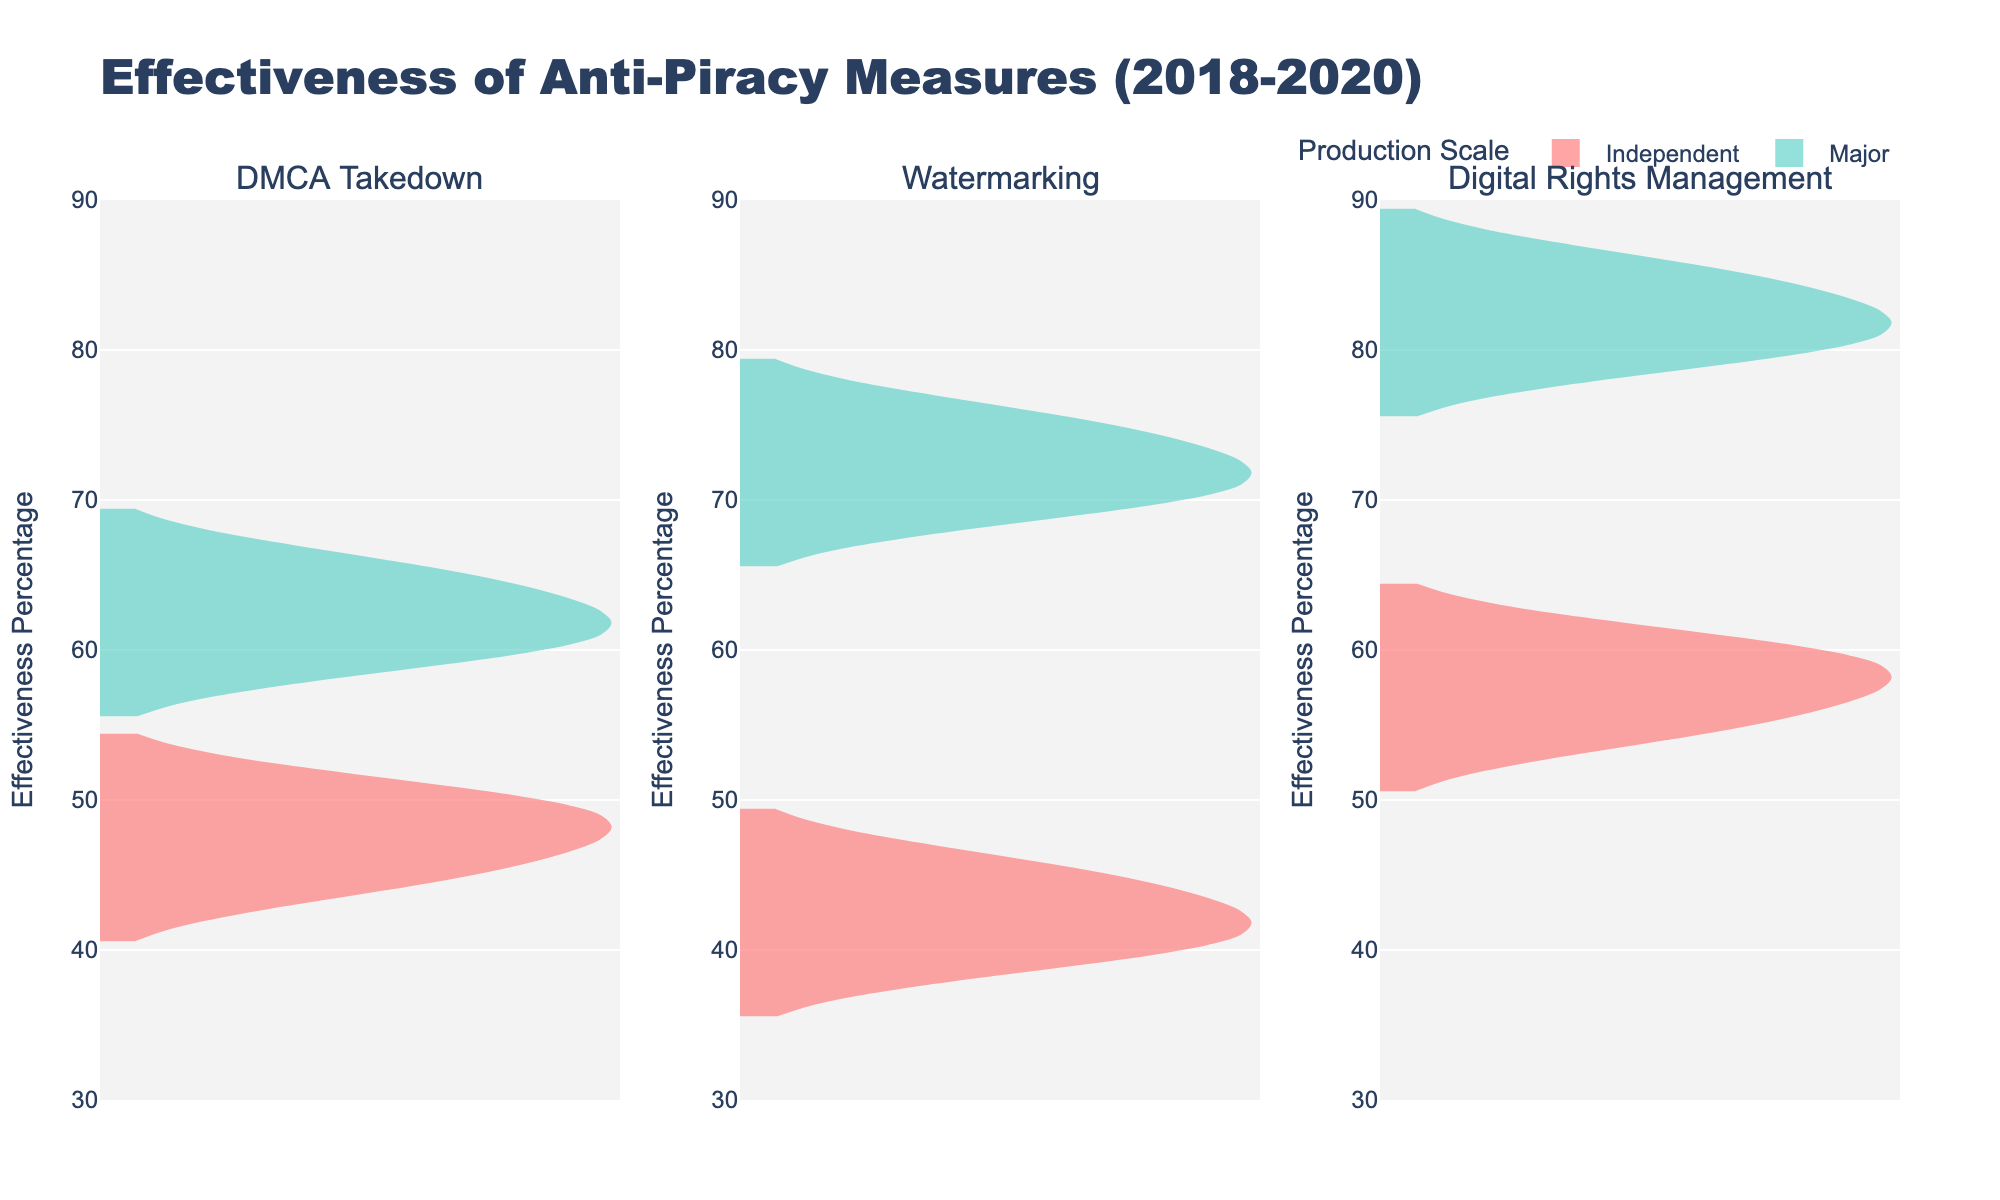Which anti-piracy measure shows the highest effectiveness for major productions in 2020? By observing the violin plots, the Digital Rights Management measure for major productions shows the highest point and median effectiveness percentage in 2020.
Answer: Digital Rights Management Which type of production (Independent or Major) shows more variation in the effectiveness of the DMCA Takedowns? By comparing the widths and spread of the violin plots for DMCA Takedowns, the Independent subplot shows more variation, indicated by a wider spread.
Answer: Independent What is the range of effectiveness percentages for watermarking in major productions? The range can be determined by observing the highest and lowest points of the watermarking violin plot for major productions. It ranges from approximately 70% to 75%.
Answer: 70% to 75% Which anti-piracy measure shows a consistent increase in effectiveness over the years for independent productions? By examining the trends in the center lines of the violin plots for independent productions across the years, both DMCA Takedown and Digital Rights Management show some increase, but Digital Rights Management shows a more notable consistency in increase.
Answer: Digital Rights Management Between DMCA Takedown and Digital Rights Management, which measure is more effective in 2018 for major productions? By comparing the median lines in the violin plots for DMCA Takedown and Digital Rights Management for major productions in 2018, Digital Rights Management shows a higher effectiveness.
Answer: Digital Rights Management What is the median effectiveness percentage of watermarking for independent productions? The median is visible as a line inside the violin plot for watermarking and independent productions, which appears around 42-45%.
Answer: 43.5% Which type of production generally benefits more from watermarking? By comparing the violin plots for watermarking independent vs. major productions, major productions show higher effectiveness percentages.
Answer: Major How does the effectiveness of DMCA Takedowns for independent productions change from 2018 to 2020? By examining the median lines for DMCA Takedowns under independent productions, we can see a slight increase from 45% in 2018 to 50% in 2020.
Answer: It increases What trend can be observed for the effectiveness of Digital Rights Management for both independent and major productions? Both independent and major productions show an increasing trend in effectiveness percentages over the years for Digital Rights Management.
Answer: Increasing trend Is the effectiveness of DMCA Takedowns better for major productions in 2019 or for watermarking in 2018? By comparing the median lines of DMCA Takedowns for major productions in 2019 (~62%) and watermarking for major productions in 2018 (~70%), watermarking in 2018 is more effective.
Answer: Watermarking in 2018 